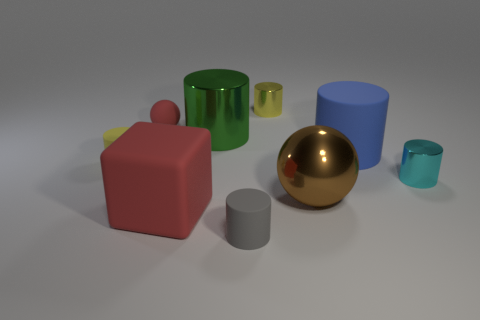Is the number of big shiny cylinders that are to the left of the brown sphere greater than the number of cylinders?
Ensure brevity in your answer.  No. How many things are behind the blue rubber thing and in front of the yellow metallic object?
Your response must be concise. 2. What is the color of the small rubber cylinder that is behind the red object that is in front of the cyan cylinder?
Your answer should be very brief. Yellow. What number of tiny cylinders are the same color as the matte block?
Your answer should be compact. 0. There is a shiny ball; does it have the same color as the small matte cylinder that is to the left of the small gray cylinder?
Provide a succinct answer. No. Is the number of green rubber blocks less than the number of brown objects?
Provide a succinct answer. Yes. Is the number of matte spheres behind the large green metallic thing greater than the number of tiny matte cylinders that are behind the large rubber cylinder?
Provide a succinct answer. Yes. Do the small cyan cylinder and the big brown thing have the same material?
Your answer should be very brief. Yes. There is a metallic cylinder behind the green object; what number of small yellow rubber cylinders are behind it?
Ensure brevity in your answer.  0. There is a tiny cylinder that is on the left side of the big green metal cylinder; does it have the same color as the big matte cube?
Your response must be concise. No. 